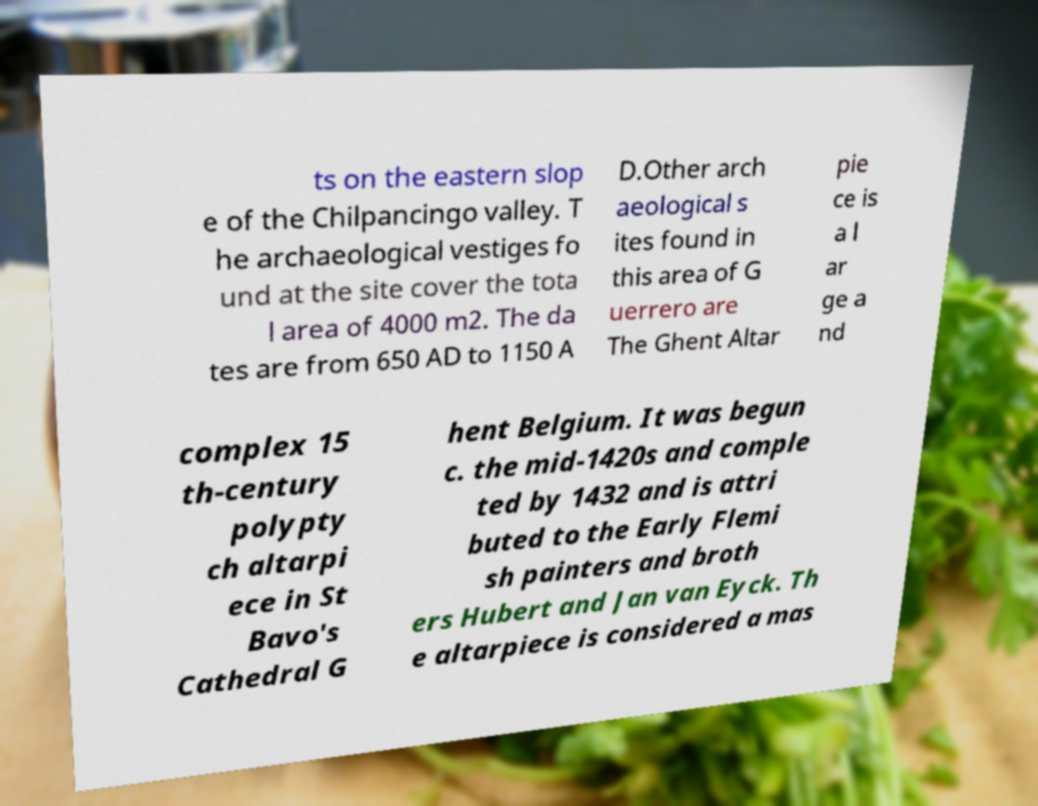I need the written content from this picture converted into text. Can you do that? ts on the eastern slop e of the Chilpancingo valley. T he archaeological vestiges fo und at the site cover the tota l area of 4000 m2. The da tes are from 650 AD to 1150 A D.Other arch aeological s ites found in this area of G uerrero are The Ghent Altar pie ce is a l ar ge a nd complex 15 th-century polypty ch altarpi ece in St Bavo's Cathedral G hent Belgium. It was begun c. the mid-1420s and comple ted by 1432 and is attri buted to the Early Flemi sh painters and broth ers Hubert and Jan van Eyck. Th e altarpiece is considered a mas 